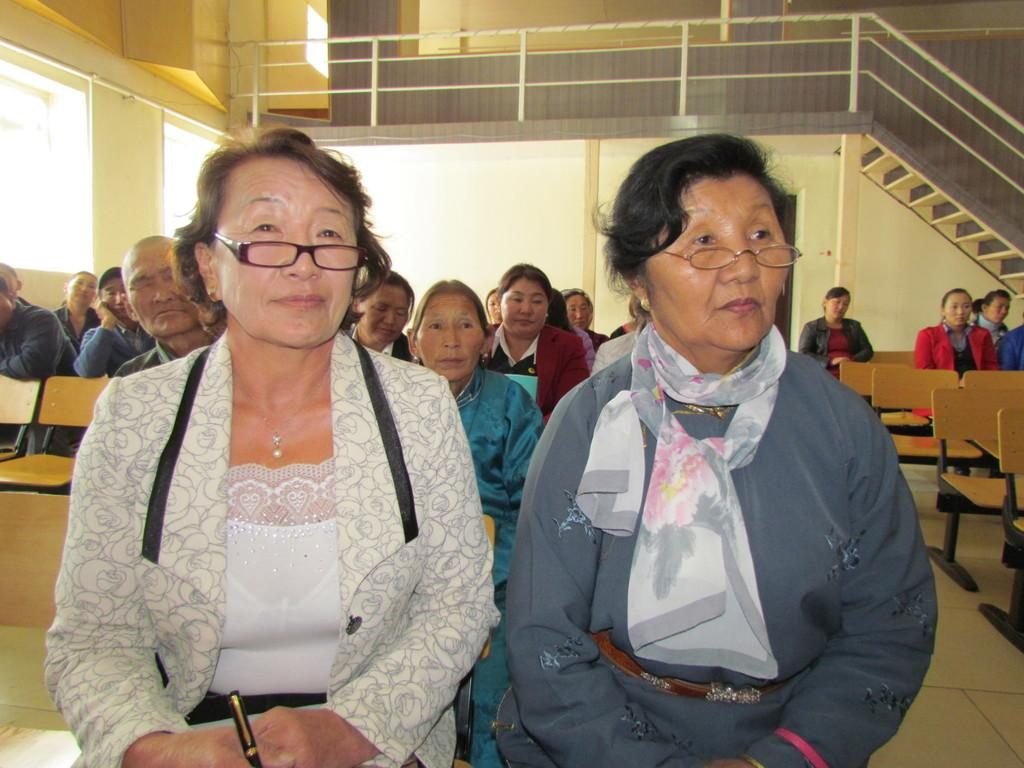How many persons can be seen in the image? There are persons in the image. What type of furniture is present in the image? There are chairs in the image. What other objects can be seen in the image? There are other objects in the image. What can be seen in the background of the image? In the background of the image, there are persons, a wall, a railing, chairs, and other objects. What is the purpose of the hill in the image? There is no hill present in the image. What type of hair can be seen on the persons in the image? The provided facts do not mention any details about the hair of the persons in the image. 